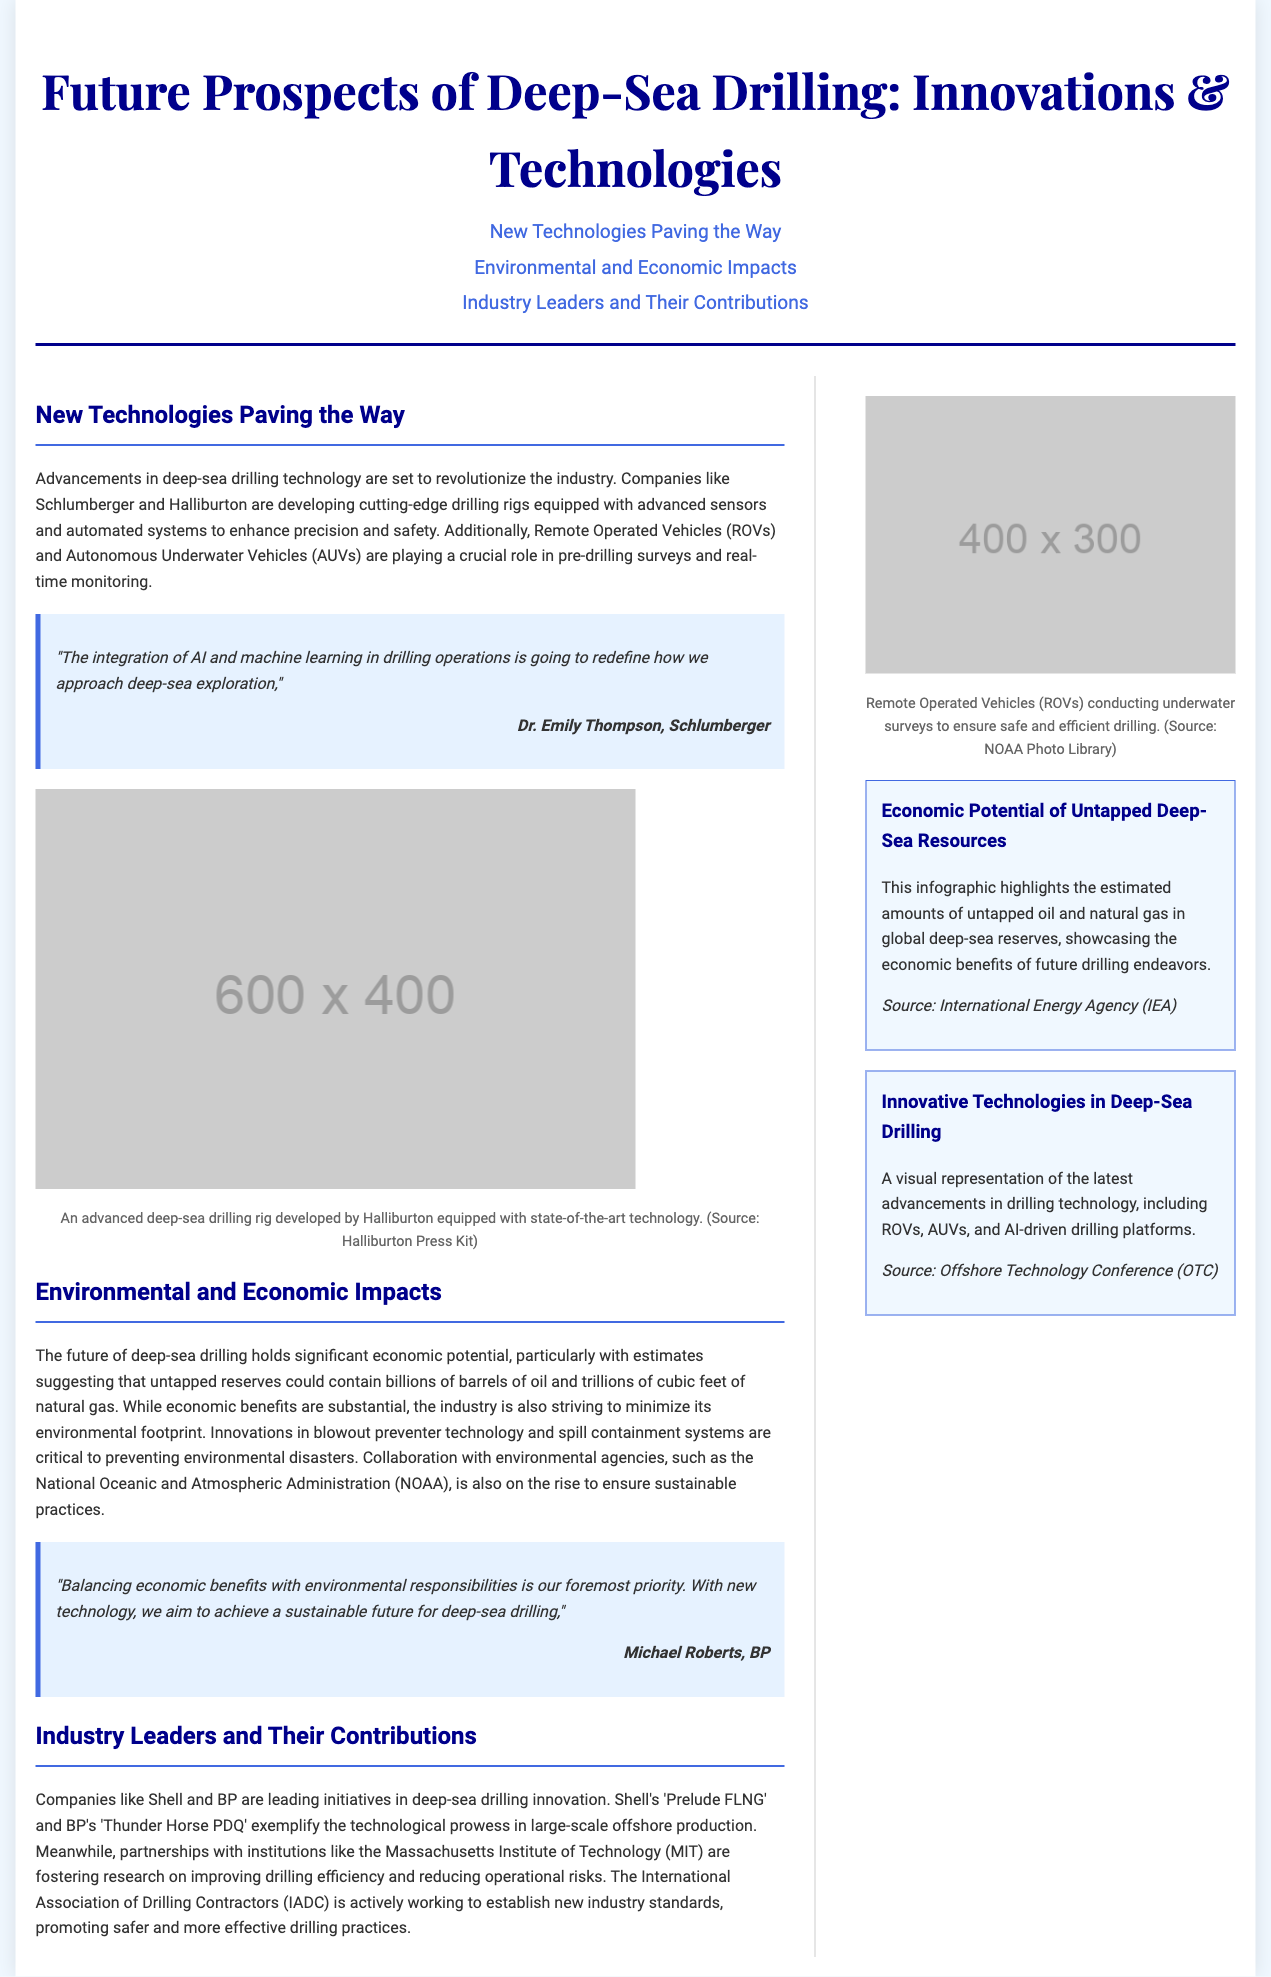What companies are developing advanced drilling rigs? The document mentions that companies like Schlumberger and Halliburton are developing advanced drilling rigs.
Answer: Schlumberger and Halliburton What technologies are ROVs and AUVs associated with? The text refers to ROVs and AUVs playing a crucial role in pre-drilling surveys and real-time monitoring.
Answer: Pre-drilling surveys and real-time monitoring Who stated that AI and machine learning will redefine deep-sea exploration? The quote in the document is attributed to Dr. Emily Thompson from Schlumberger regarding the impact of AI and machine learning on exploration.
Answer: Dr. Emily Thompson What is the name of Shell's large-scale offshore production project? The document lists Shell's 'Prelude FLNG' as an example of a large-scale offshore production project.
Answer: Prelude FLNG What is the focus of the International Association of Drilling Contractors? The document states that the IADC is working to establish new industry standards, promoting safer and more effective drilling practices.
Answer: Establish new industry standards How many barrels of oil do untapped reserves potentially contain? The document suggests that untapped reserves could contain billions of barrels of oil.
Answer: Billions What is the economic potential highlighted in the infographic? The infographic outlines the estimated amounts of untapped oil and natural gas in global deep-sea reserves.
Answer: Untapped oil and natural gas What is the priority mentioned by Michael Roberts from BP? Michael Roberts emphasizes balancing economic benefits with environmental responsibilities as the foremost priority.
Answer: Balancing economic benefits with environmental responsibilities 